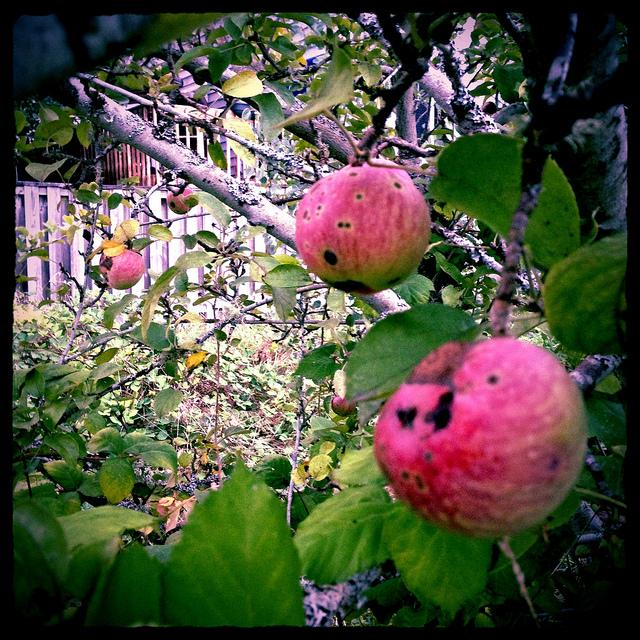Why are there black spots on the apples? bugs 